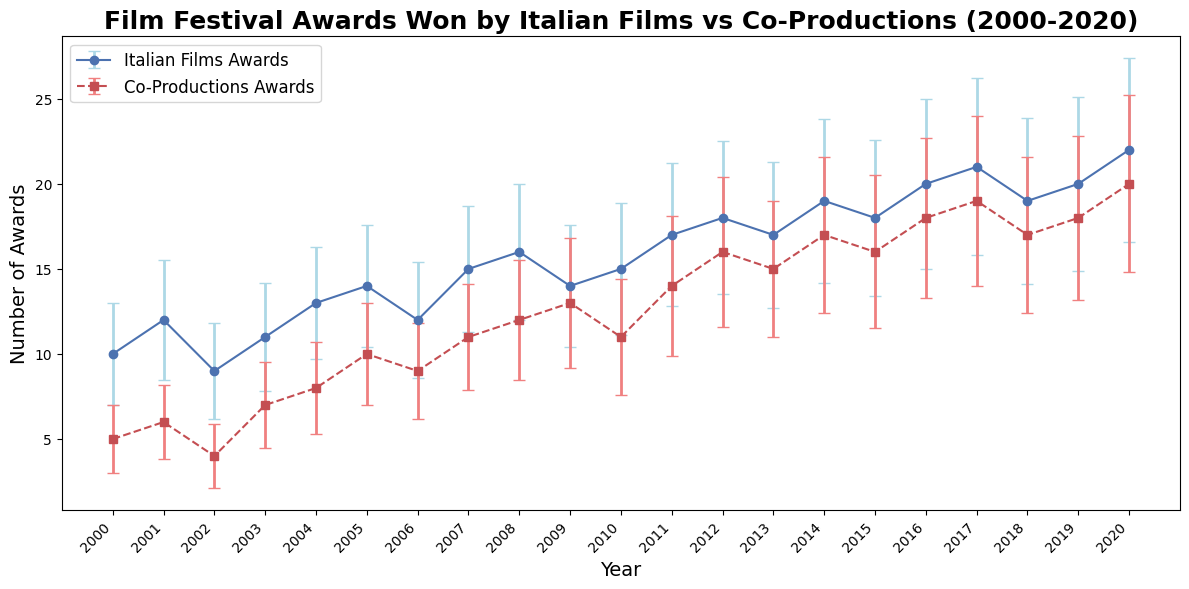What's the difference in the number of awards won by Italian films and co-productions in 2020? In 2020, Italian films won 22 awards and co-productions won 20 awards. The difference can be calculated as 22 - 20.
Answer: 2 What is the trend of awards won by Italian films from 2000 to 2020? The plot shows that the number of awards won by Italian films generally increased over the period from 10 awards in 2000 to 22 awards in 2020.
Answer: Increased Which year saw the highest number of awards for co-productions? According to the plot, the highest number of awards for co-productions was in 2020, where they won 20 awards.
Answer: 2020 How does the error margin for nominations compare between Italian films and co-productions in 2015? In 2015, the error margin for nominations for Italian films is 46 * 0.1 = 4.6, and for co-productions, it is 45 * 0.1 = 4.5. Therefore, the error margin for nominations for Italian films is slightly higher than co-productions.
Answer: Italian films have a slightly higher error margin How many more awards did Italian films win compared to co-productions in 2005? In 2005, Italian films won 14 awards, while co-productions won 10 awards. The difference can be calculated as 14 - 10.
Answer: 4 What was the average number of awards won by Italian films between 2000 and 2020? Sum the number of awards won by Italian films from 2000 to 2020 and then divide by the number of years: (10+12+9+11+13+14+12+15+16+14+15+17+18+17+19+18+20+21+19+20+22)/21. The sum is 328, so the average is 328/21 ≈ 15.62.
Answer: 15.62 Did Italian films or co-productions have a higher variability in nominations in 2010? The errorbars indicate the variability in nominations. In 2010, the error margin for Italian films is 39 * 0.1 = 3.9, and for co-productions, it is 34 * 0.1 = 3.4, hence Italian films have higher variability in nominations.
Answer: Italian films Which group, Italian films or co-productions, showed more consistent nominations over the years? Examining the error bars throughout the years, Italian films generally show larger error margins compared to co-productions, suggesting that co-productions have more consistent nominations.
Answer: Co-productions What is the overall trend in awards won by co-productions from 2000 to 2020? The number of awards won by co-productions generally increased over the period from 5 awards in 2000 to 20 awards in 2020.
Answer: Increased 